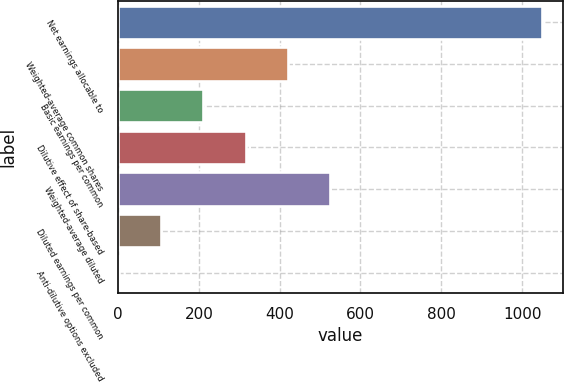Convert chart to OTSL. <chart><loc_0><loc_0><loc_500><loc_500><bar_chart><fcel>Net earnings allocable to<fcel>Weighted-average common shares<fcel>Basic earnings per common<fcel>Dilutive effect of share-based<fcel>Weighted-average diluted<fcel>Diluted earnings per common<fcel>Anti-dilutive options excluded<nl><fcel>1048<fcel>420.46<fcel>211.28<fcel>315.87<fcel>525.05<fcel>106.69<fcel>2.1<nl></chart> 